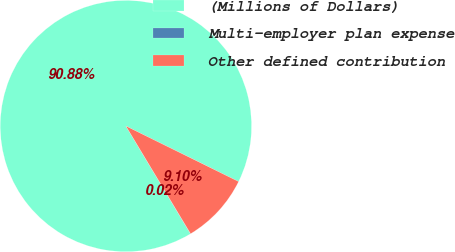Convert chart to OTSL. <chart><loc_0><loc_0><loc_500><loc_500><pie_chart><fcel>(Millions of Dollars)<fcel>Multi-employer plan expense<fcel>Other defined contribution<nl><fcel>90.88%<fcel>0.02%<fcel>9.1%<nl></chart> 